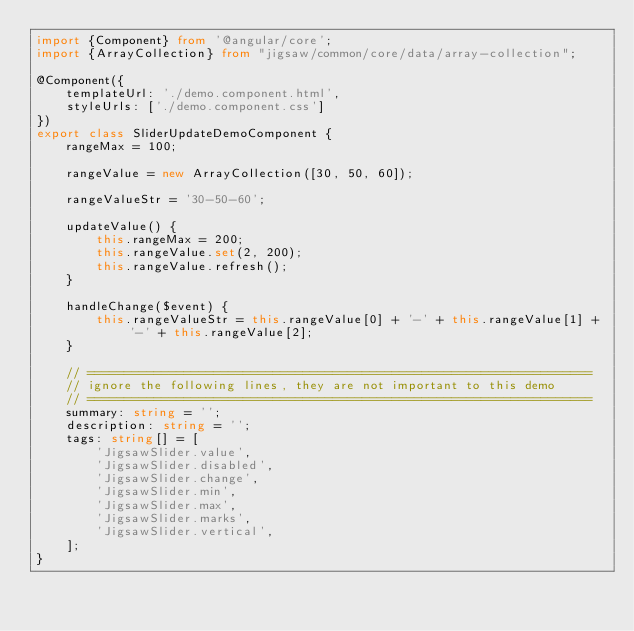Convert code to text. <code><loc_0><loc_0><loc_500><loc_500><_TypeScript_>import {Component} from '@angular/core';
import {ArrayCollection} from "jigsaw/common/core/data/array-collection";

@Component({
    templateUrl: './demo.component.html',
    styleUrls: ['./demo.component.css']
})
export class SliderUpdateDemoComponent {
    rangeMax = 100;

    rangeValue = new ArrayCollection([30, 50, 60]);

    rangeValueStr = '30-50-60';

    updateValue() {
        this.rangeMax = 200;
        this.rangeValue.set(2, 200);
        this.rangeValue.refresh();
    }

    handleChange($event) {
        this.rangeValueStr = this.rangeValue[0] + '-' + this.rangeValue[1] + '-' + this.rangeValue[2];
    }

    // ====================================================================
    // ignore the following lines, they are not important to this demo
    // ====================================================================
    summary: string = '';
    description: string = '';
    tags: string[] = [
        'JigsawSlider.value',
        'JigsawSlider.disabled',
        'JigsawSlider.change',
        'JigsawSlider.min',
        'JigsawSlider.max',
        'JigsawSlider.marks',
        'JigsawSlider.vertical',
    ];
}
</code> 